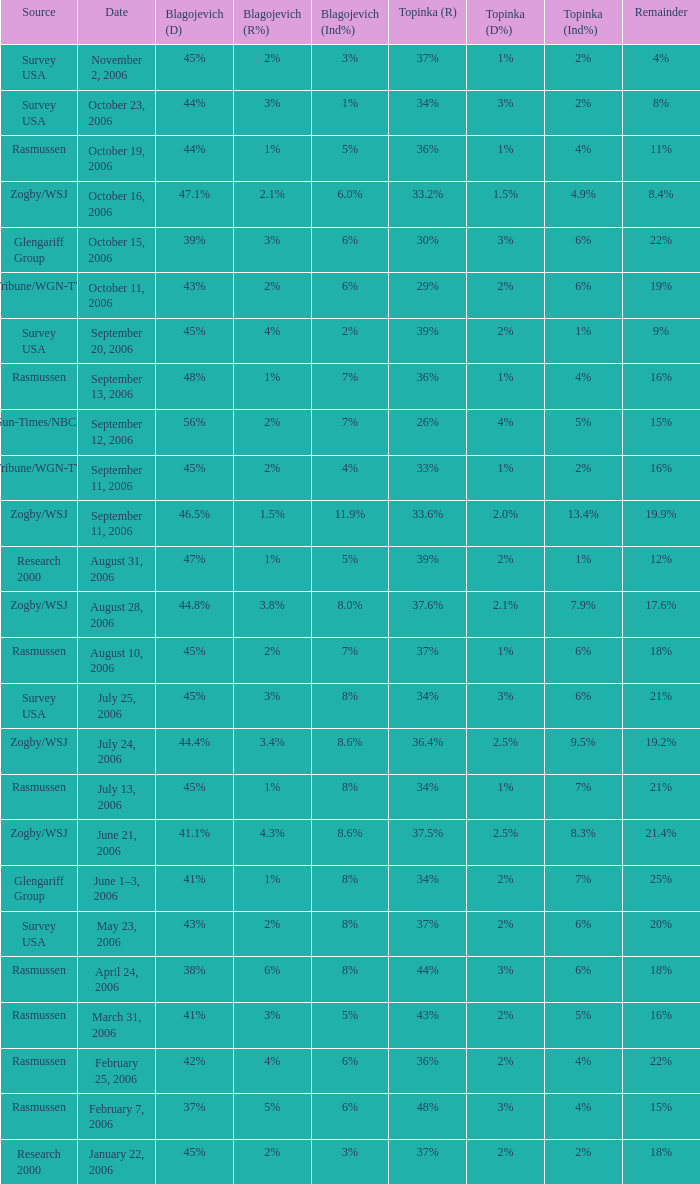Which Source has a Remainder of 15%, and a Topinka of 26%? Sun-Times/NBC5. 